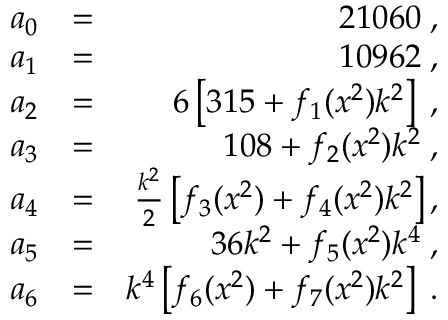<formula> <loc_0><loc_0><loc_500><loc_500>\begin{array} { r l r } { a _ { 0 } } & { = } & { 2 1 0 6 0 \, , } \\ { a _ { 1 } } & { = } & { 1 0 9 6 2 \, , } \\ { a _ { 2 } } & { = } & { 6 \left [ 3 1 5 + f _ { 1 } ( x ^ { 2 } ) k ^ { 2 } \right ] \, , } \\ { a _ { 3 } } & { = } & { 1 0 8 + f _ { 2 } ( x ^ { 2 } ) k ^ { 2 } \, , } \\ { a _ { 4 } } & { = } & { \frac { k ^ { 2 } } { 2 } \left [ f _ { 3 } ( x ^ { 2 } ) + f _ { 4 } ( x ^ { 2 } ) k ^ { 2 } \right ] , } \\ { a _ { 5 } } & { = } & { 3 6 k ^ { 2 } + f _ { 5 } ( x ^ { 2 } ) k ^ { 4 } \, , } \\ { a _ { 6 } } & { = } & { k ^ { 4 } \left [ f _ { 6 } ( x ^ { 2 } ) + f _ { 7 } ( x ^ { 2 } ) k ^ { 2 } \right ] \, . } \end{array}</formula> 